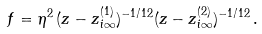Convert formula to latex. <formula><loc_0><loc_0><loc_500><loc_500>f = \eta ^ { 2 } \, ( z - z ^ { ( 1 ) } _ { i \infty } ) ^ { - 1 / 1 2 } ( z - z ^ { ( 2 ) } _ { i \infty } ) ^ { - 1 / 1 2 } \, .</formula> 